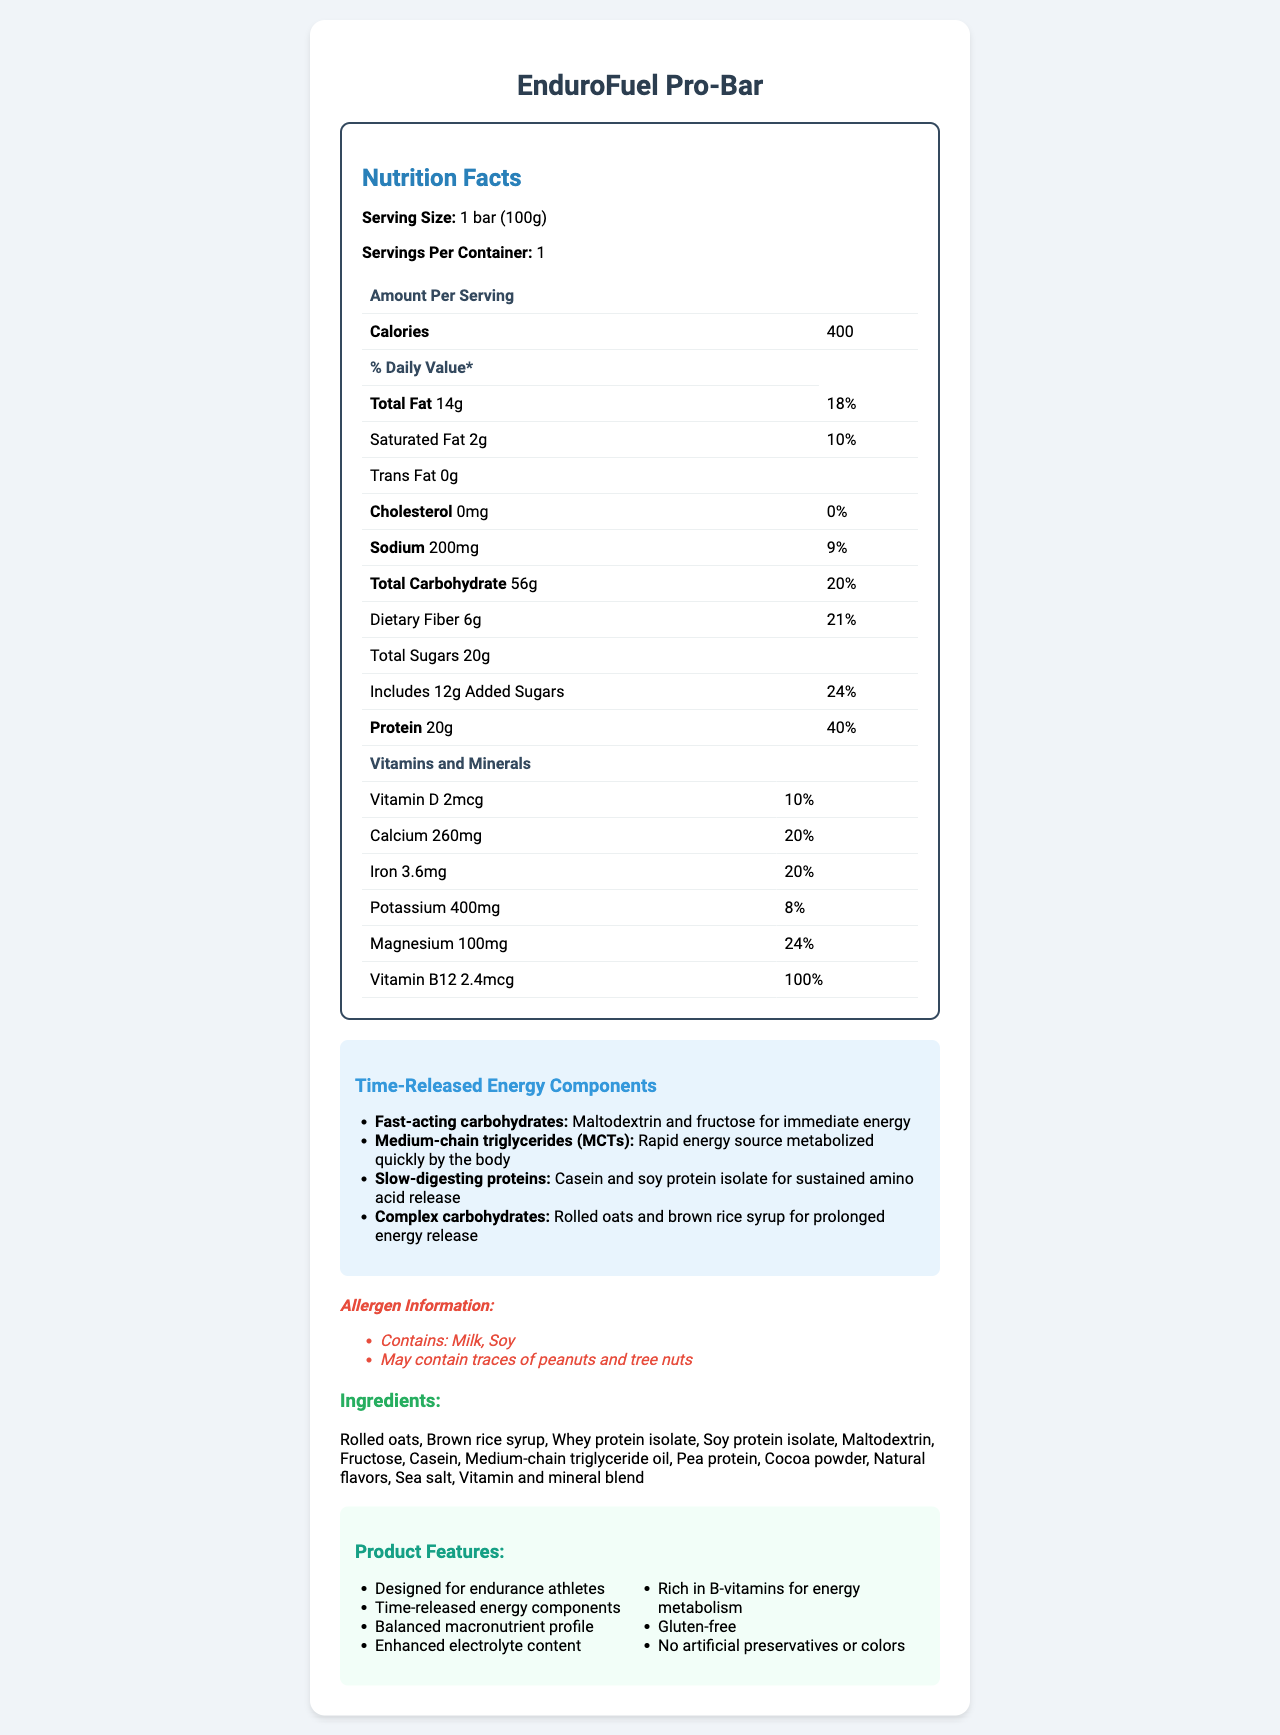what is the serving size of the EnduroFuel Pro-Bar? The serving size is specified as "1 bar (100g)" in the document.
Answer: 1 bar (100g) how many calories are in one serving of the meal replacement bar? The document states that each serving contains 400 calories.
Answer: 400 calories what is the amount of protein per serving and its % Daily Value? The protein amount per serving is 20g and it contributes 40% to the Daily Value, as per the nutrition facts.
Answer: 20g, 40% list three time-released energy components included in the EnduroFuel Pro-Bar. These three components are listed under the "Time-Released Energy Components" section along with their descriptions.
Answer: Fast-acting carbohydrates, Medium-chain triglycerides (MCTs), Slow-digesting proteins what vitamins and minerals are listed on the nutrition facts label? The vitamins and minerals listed include Vitamin D, Calcium, Iron, Potassium, Magnesium, and Vitamin B12 along with their amounts and % Daily Values.
Answer: Vitamin D, Calcium, Iron, Potassium, Magnesium, Vitamin B12 which of the following is a feature of the EnduroFuel Pro-Bar? A. Artificial preservatives B. Gluten-free C. Low protein The document lists "Gluten-free" as one of the product features.
Answer: B what percentage of Daily Value does Magnesium contribute to? A. 10% B. 20% C. 24% The % Daily Value for Magnesium is 24%, as detailed in the vitamins and minerals section.
Answer: C does the product contain any allergens? The allergen information mentions that the product contains milk and soy, and may contain traces of peanuts and tree nuts.
Answer: Yes does the EnduroFuel Pro-Bar contain any cholesterol? The document indicates that there is 0mg of cholesterol present in the product.
Answer: No summarize the main idea of the EnduroFuel Pro-Bar nutrition facts label. The nutrition facts label highlights its suitability for endurance athletes, detailed energy components, nutritional profile, allergen information, and ethical sustainability practices.
Answer: The EnduroFuel Pro-Bar is a meal replacement bar designed for endurance athletes, featuring time-released energy components, a balanced macronutrient profile, and enhanced vitamins and minerals. It provides 400 calories, 20g of protein, and is gluten-free, with no artificial preservatives or colors. how does the product's carbon footprint compare to other meal replacement bars? The document mentions the product has a "30% lower than average meal replacement bar" carbon footprint but does not provide the actual carbon footprint values for comparisons.
Answer: Not enough information. 